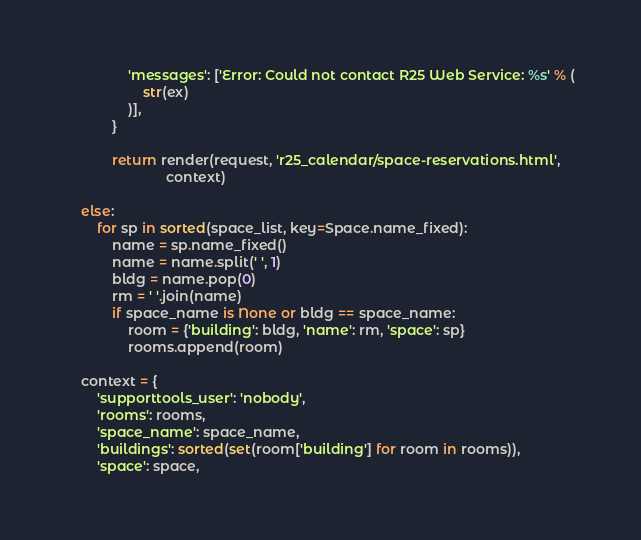Convert code to text. <code><loc_0><loc_0><loc_500><loc_500><_Python_>                'messages': ['Error: Could not contact R25 Web Service: %s' % (
                    str(ex)
                )],
            }

            return render(request, 'r25_calendar/space-reservations.html',
                          context)

    else:
        for sp in sorted(space_list, key=Space.name_fixed):
            name = sp.name_fixed()
            name = name.split(' ', 1)
            bldg = name.pop(0)
            rm = ' '.join(name)
            if space_name is None or bldg == space_name:
                room = {'building': bldg, 'name': rm, 'space': sp}
                rooms.append(room)

    context = {
        'supporttools_user': 'nobody',
        'rooms': rooms,
        'space_name': space_name,
        'buildings': sorted(set(room['building'] for room in rooms)),
        'space': space,</code> 